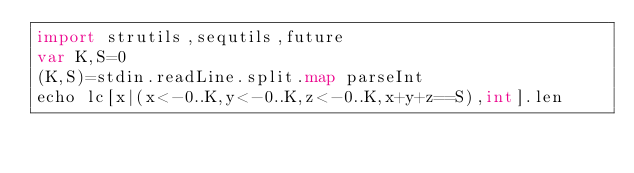<code> <loc_0><loc_0><loc_500><loc_500><_Nim_>import strutils,sequtils,future
var K,S=0
(K,S)=stdin.readLine.split.map parseInt
echo lc[x|(x<-0..K,y<-0..K,z<-0..K,x+y+z==S),int].len</code> 